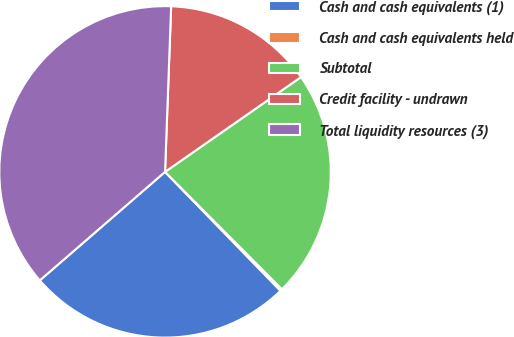Convert chart to OTSL. <chart><loc_0><loc_0><loc_500><loc_500><pie_chart><fcel>Cash and cash equivalents (1)<fcel>Cash and cash equivalents held<fcel>Subtotal<fcel>Credit facility - undrawn<fcel>Total liquidity resources (3)<nl><fcel>25.9%<fcel>0.2%<fcel>22.23%<fcel>14.72%<fcel>36.95%<nl></chart> 